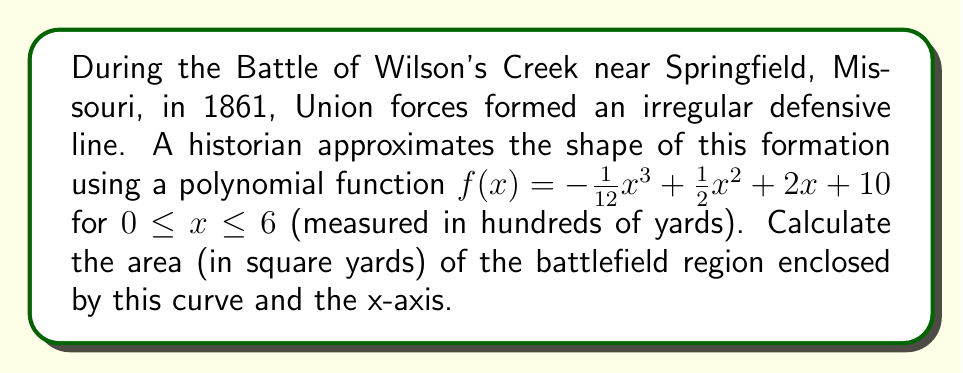Show me your answer to this math problem. To find the area enclosed by the curve and the x-axis, we need to integrate the function over the given interval:

1) The area is given by the definite integral:

   $$A = \int_0^6 f(x) dx$$

2) Substituting the function:

   $$A = \int_0^6 (-\frac{1}{12}x^3 + \frac{1}{2}x^2 + 2x + 10) dx$$

3) Integrate term by term:

   $$A = [-\frac{1}{48}x^4 + \frac{1}{6}x^3 + x^2 + 10x]_0^6$$

4) Evaluate at the limits:

   $$A = [-\frac{1}{48}(6^4) + \frac{1}{6}(6^3) + (6^2) + 10(6)] - [-\frac{1}{48}(0^4) + \frac{1}{6}(0^3) + (0^2) + 10(0)]$$

5) Simplify:

   $$A = [-54 + 72 + 36 + 60] - [0]$$
   $$A = 114$$

6) Since x was measured in hundreds of yards, we need to multiply by 10,000 to convert to square yards:

   $$A = 114 \times 10,000 = 1,140,000$$ square yards
Answer: 1,140,000 square yards 